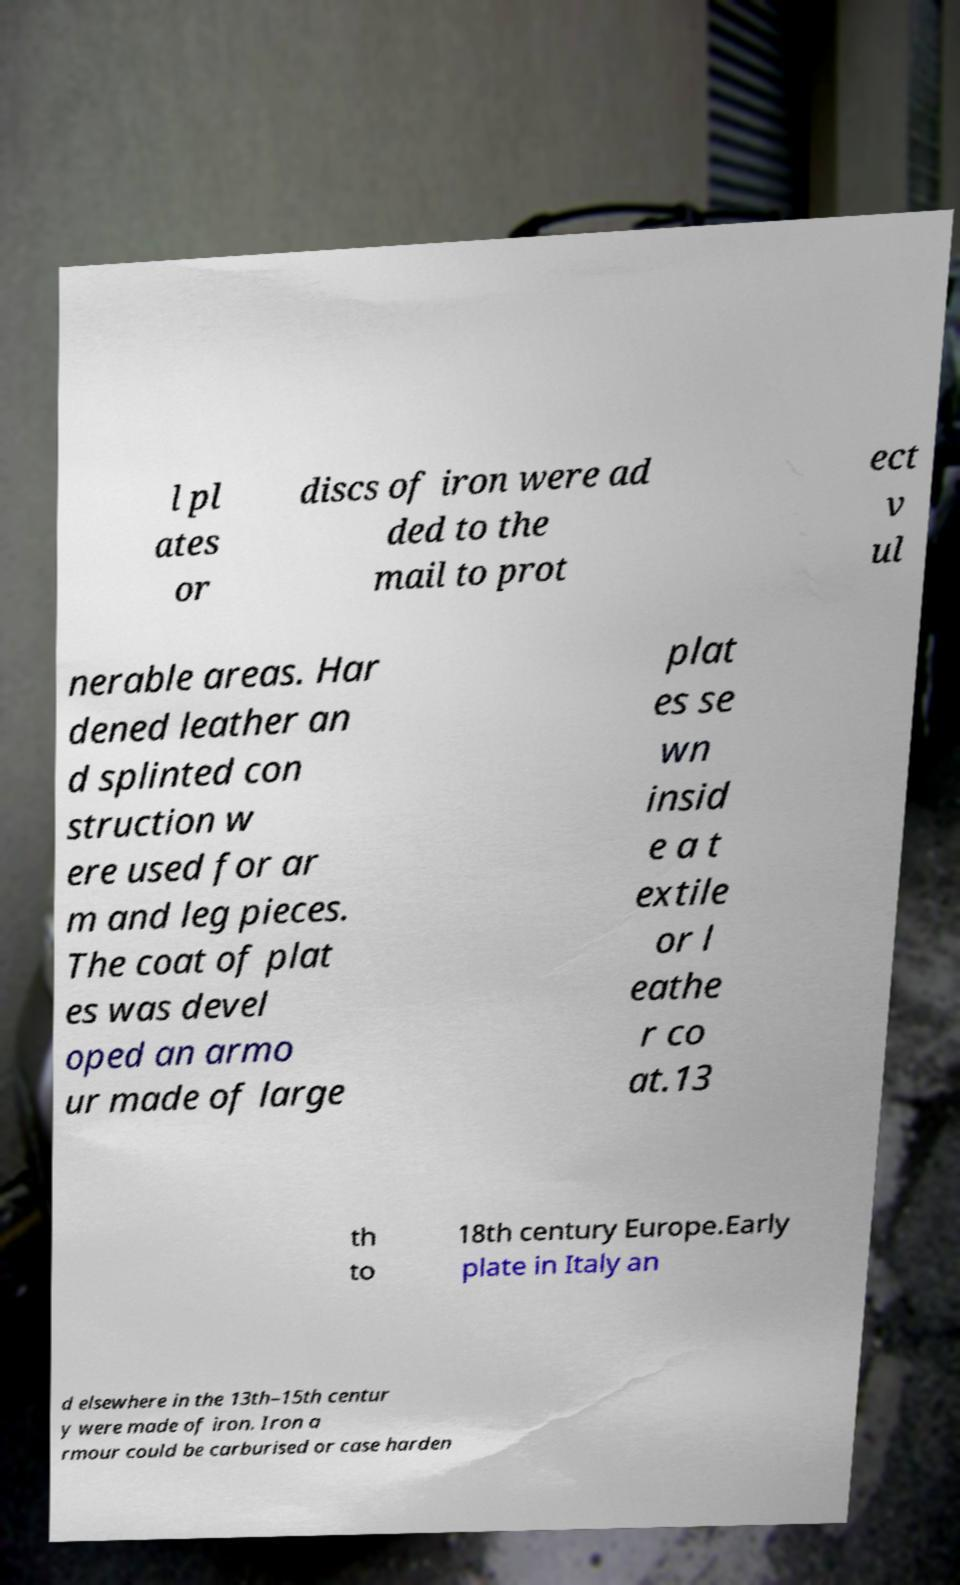Could you assist in decoding the text presented in this image and type it out clearly? l pl ates or discs of iron were ad ded to the mail to prot ect v ul nerable areas. Har dened leather an d splinted con struction w ere used for ar m and leg pieces. The coat of plat es was devel oped an armo ur made of large plat es se wn insid e a t extile or l eathe r co at.13 th to 18th century Europe.Early plate in Italy an d elsewhere in the 13th–15th centur y were made of iron. Iron a rmour could be carburised or case harden 